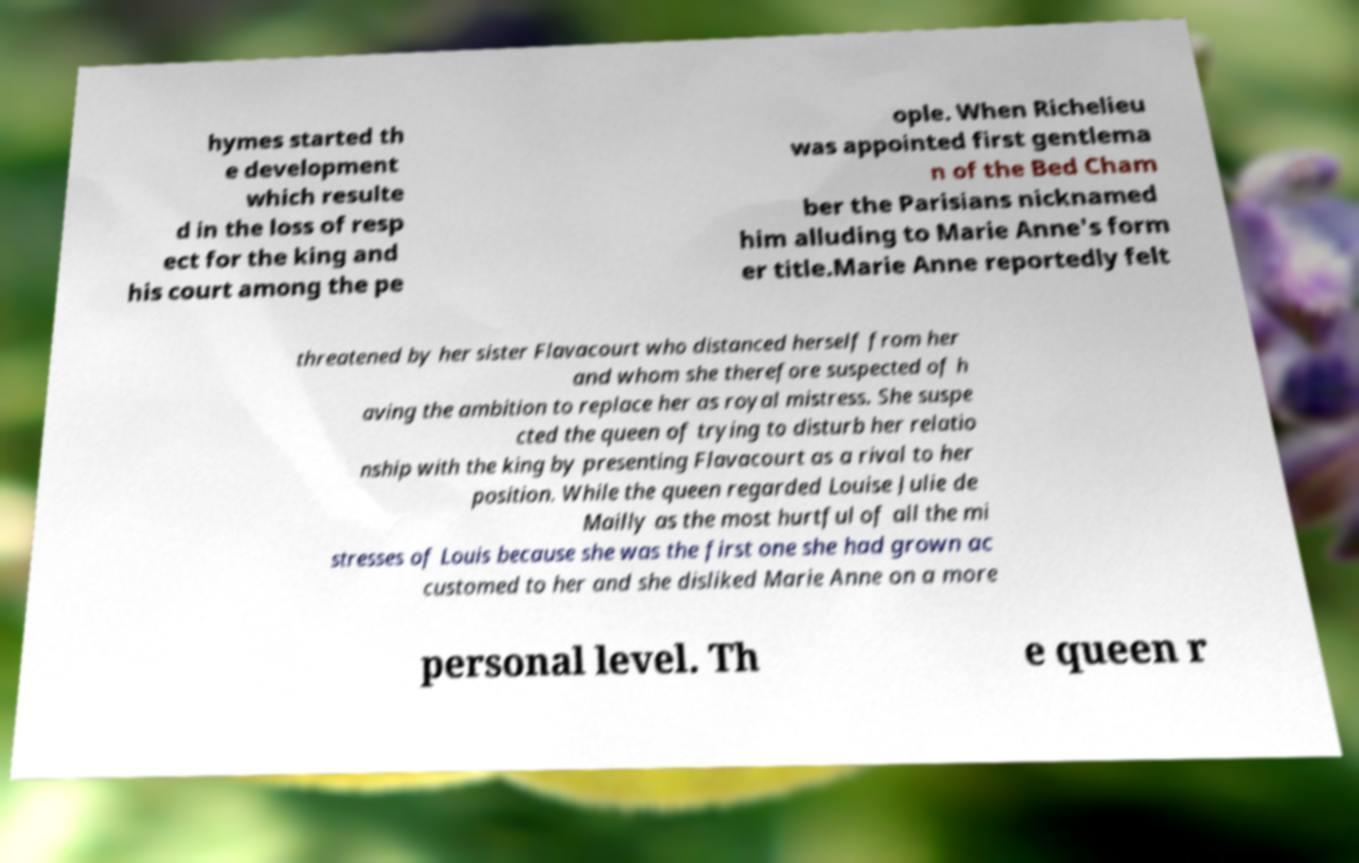There's text embedded in this image that I need extracted. Can you transcribe it verbatim? hymes started th e development which resulte d in the loss of resp ect for the king and his court among the pe ople. When Richelieu was appointed first gentlema n of the Bed Cham ber the Parisians nicknamed him alluding to Marie Anne's form er title.Marie Anne reportedly felt threatened by her sister Flavacourt who distanced herself from her and whom she therefore suspected of h aving the ambition to replace her as royal mistress. She suspe cted the queen of trying to disturb her relatio nship with the king by presenting Flavacourt as a rival to her position. While the queen regarded Louise Julie de Mailly as the most hurtful of all the mi stresses of Louis because she was the first one she had grown ac customed to her and she disliked Marie Anne on a more personal level. Th e queen r 